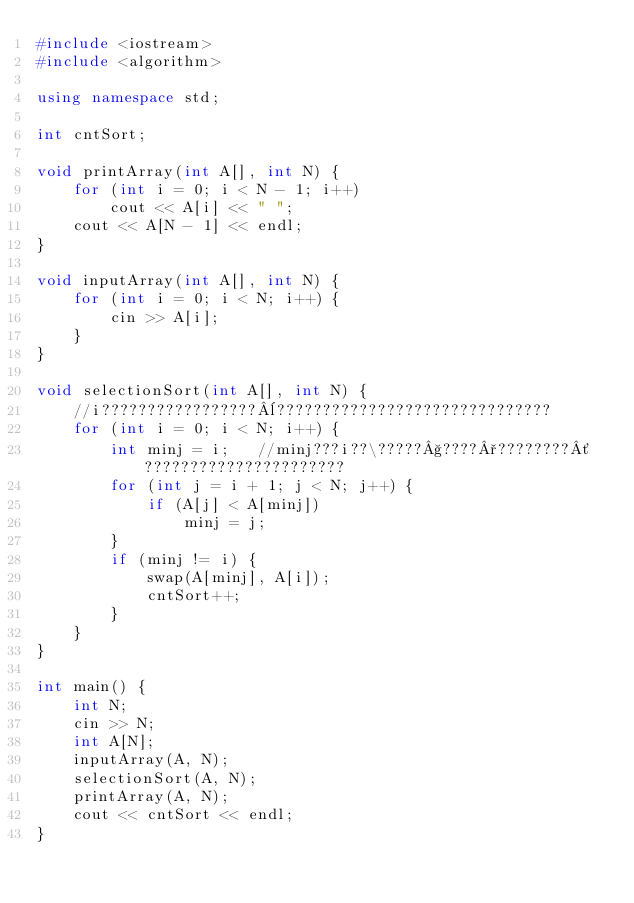<code> <loc_0><loc_0><loc_500><loc_500><_C++_>#include <iostream>
#include <algorithm>

using namespace std;

int cntSort;

void printArray(int A[], int N) {
	for (int i = 0; i < N - 1; i++)
		cout << A[i] << " ";
	cout << A[N - 1] << endl;
}

void inputArray(int A[], int N) {
	for (int i = 0; i < N; i++) {
		cin >> A[i];
	}
}

void selectionSort(int A[], int N) {
	//i?????????????????¨??????????????????????????????
	for (int i = 0; i < N; i++) {
		int minj = i;	//minj???i??\?????§????°????????´??????????????????????
		for (int j = i + 1; j < N; j++) {
			if (A[j] < A[minj])
				minj = j;
		}
		if (minj != i) {
			swap(A[minj], A[i]);
			cntSort++;
		}
	}
}

int main() {
	int N;
	cin >> N;
	int A[N];
	inputArray(A, N);
	selectionSort(A, N);
	printArray(A, N);
	cout << cntSort << endl;
}</code> 